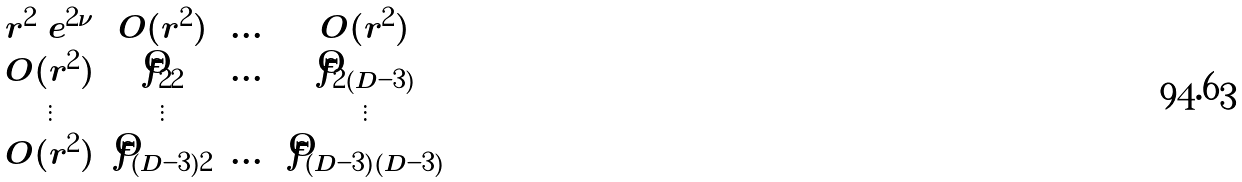<formula> <loc_0><loc_0><loc_500><loc_500>\begin{matrix} r ^ { 2 } \ e ^ { 2 \nu } & O ( r ^ { 2 } ) & \dots & O ( r ^ { 2 } ) \\ O ( r ^ { 2 } ) & \hat { f } _ { 2 2 } & \dots & \hat { f } _ { 2 ( D - 3 ) } \\ \vdots & \vdots & & \vdots \\ O ( r ^ { 2 } ) & \hat { f } _ { ( D - 3 ) 2 } & \dots & \hat { f } _ { ( D - 3 ) ( D - 3 ) } \end{matrix}</formula> 